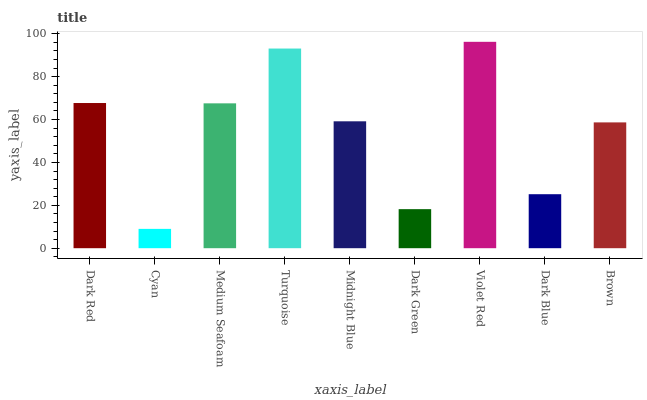Is Cyan the minimum?
Answer yes or no. Yes. Is Violet Red the maximum?
Answer yes or no. Yes. Is Medium Seafoam the minimum?
Answer yes or no. No. Is Medium Seafoam the maximum?
Answer yes or no. No. Is Medium Seafoam greater than Cyan?
Answer yes or no. Yes. Is Cyan less than Medium Seafoam?
Answer yes or no. Yes. Is Cyan greater than Medium Seafoam?
Answer yes or no. No. Is Medium Seafoam less than Cyan?
Answer yes or no. No. Is Midnight Blue the high median?
Answer yes or no. Yes. Is Midnight Blue the low median?
Answer yes or no. Yes. Is Dark Blue the high median?
Answer yes or no. No. Is Violet Red the low median?
Answer yes or no. No. 